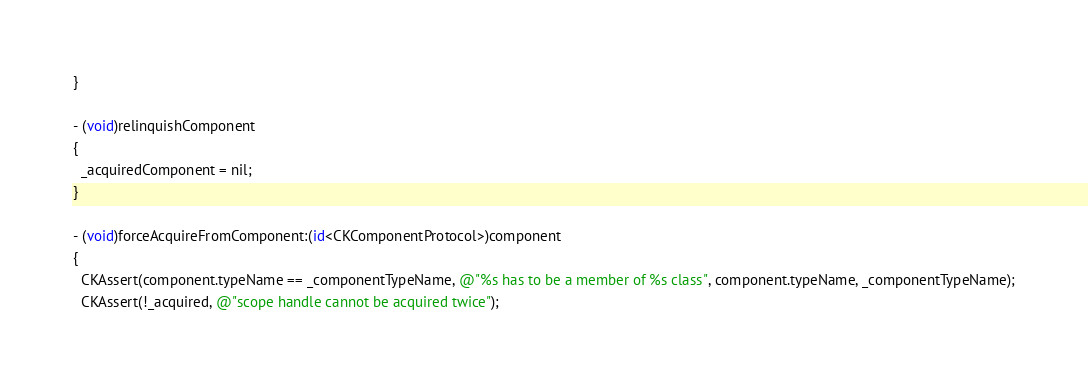<code> <loc_0><loc_0><loc_500><loc_500><_ObjectiveC_>}

- (void)relinquishComponent
{
  _acquiredComponent = nil;
}

- (void)forceAcquireFromComponent:(id<CKComponentProtocol>)component
{
  CKAssert(component.typeName == _componentTypeName, @"%s has to be a member of %s class", component.typeName, _componentTypeName);
  CKAssert(!_acquired, @"scope handle cannot be acquired twice");</code> 